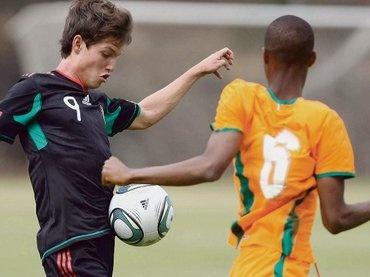Describe the objects in this image and their specific colors. I can see people in black, orange, maroon, and red tones, people in black and gray tones, and sports ball in black, lightgray, darkgray, and gray tones in this image. 